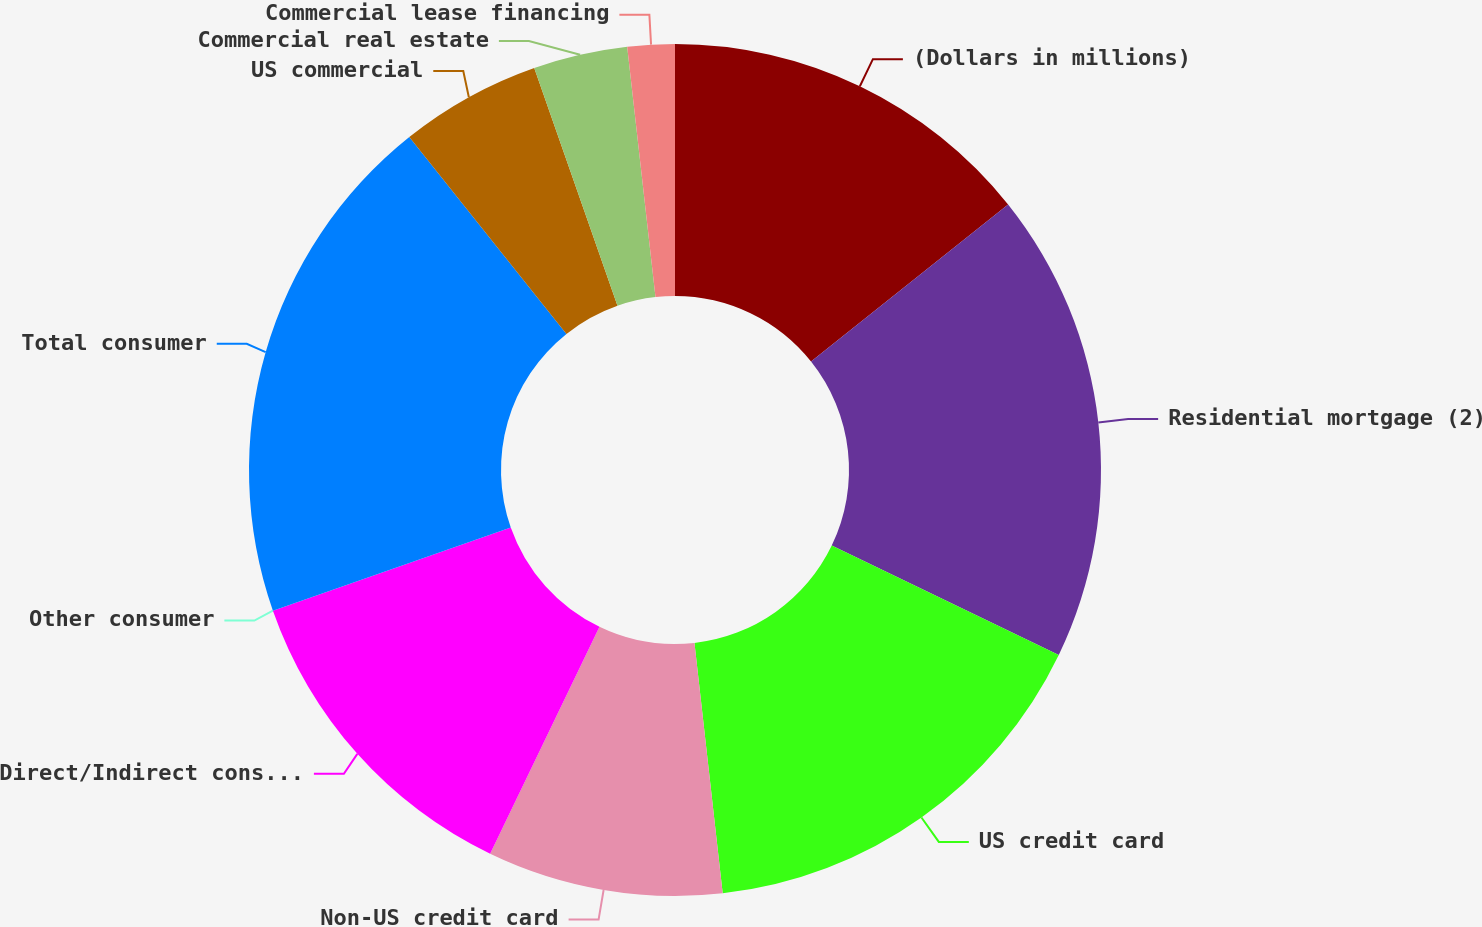Convert chart to OTSL. <chart><loc_0><loc_0><loc_500><loc_500><pie_chart><fcel>(Dollars in millions)<fcel>Residential mortgage (2)<fcel>US credit card<fcel>Non-US credit card<fcel>Direct/Indirect consumer<fcel>Other consumer<fcel>Total consumer<fcel>US commercial<fcel>Commercial real estate<fcel>Commercial lease financing<nl><fcel>14.29%<fcel>17.86%<fcel>16.07%<fcel>8.93%<fcel>12.5%<fcel>0.0%<fcel>19.64%<fcel>5.36%<fcel>3.57%<fcel>1.79%<nl></chart> 